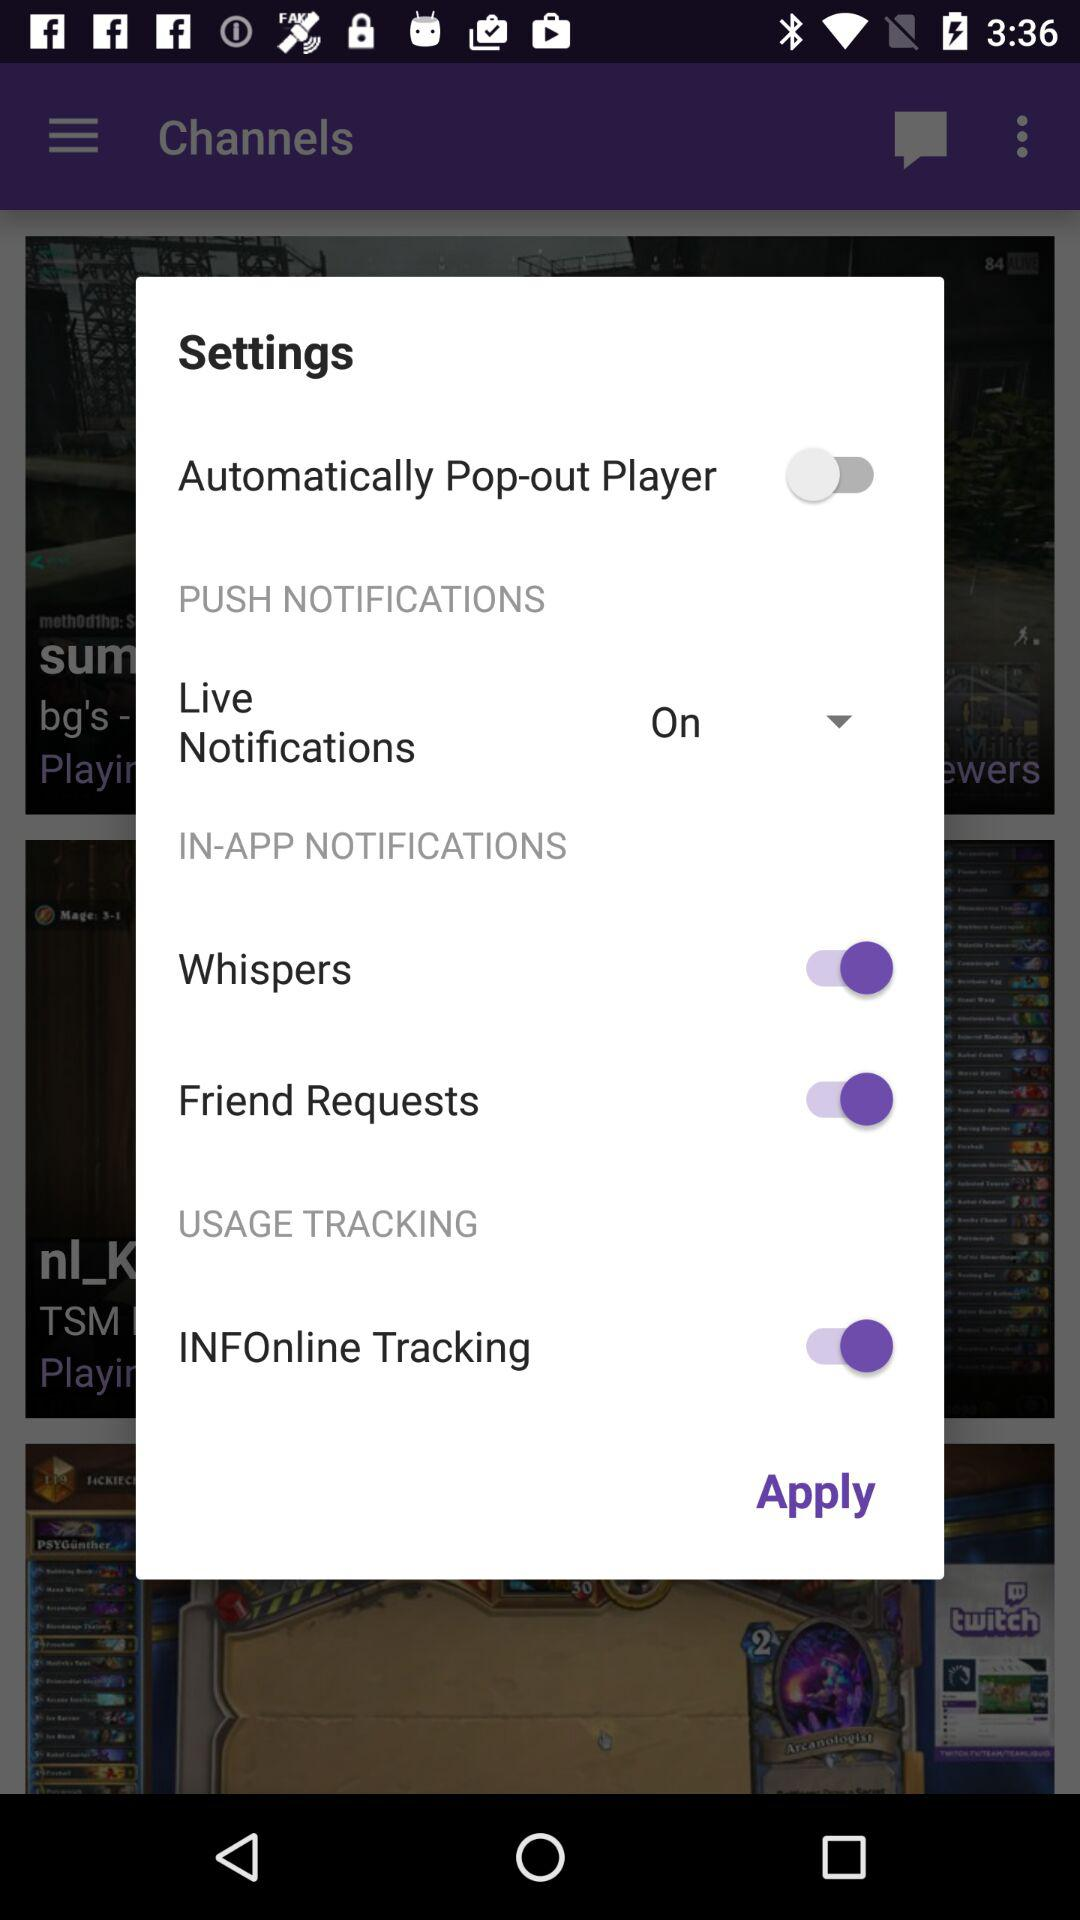What is the status of "Live Notifications"? The status is "on". 